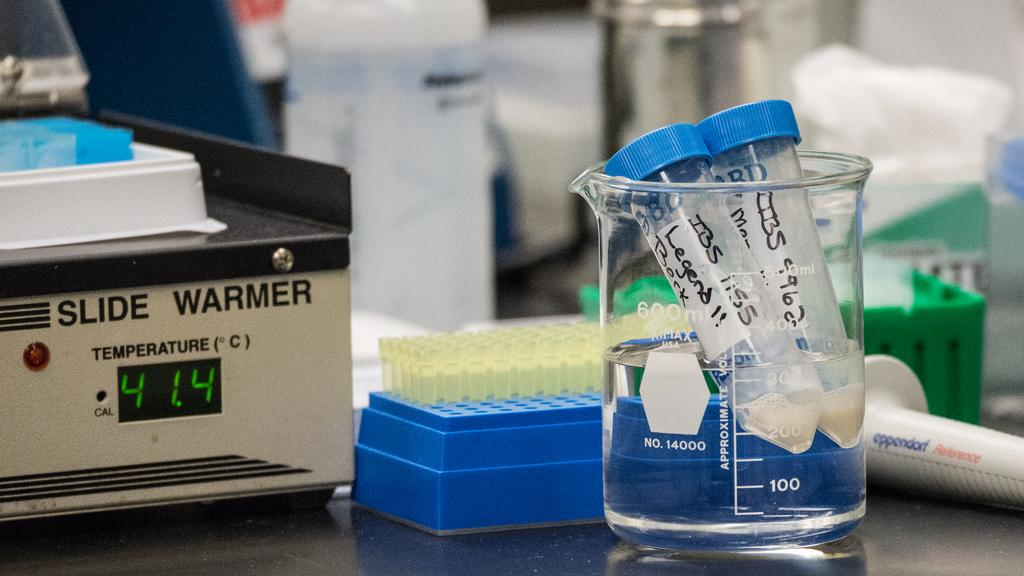Provide a one-sentence caption for the provided image. A machine showing the temperature of 41.4 C is sitting on the table next to some tubes. 